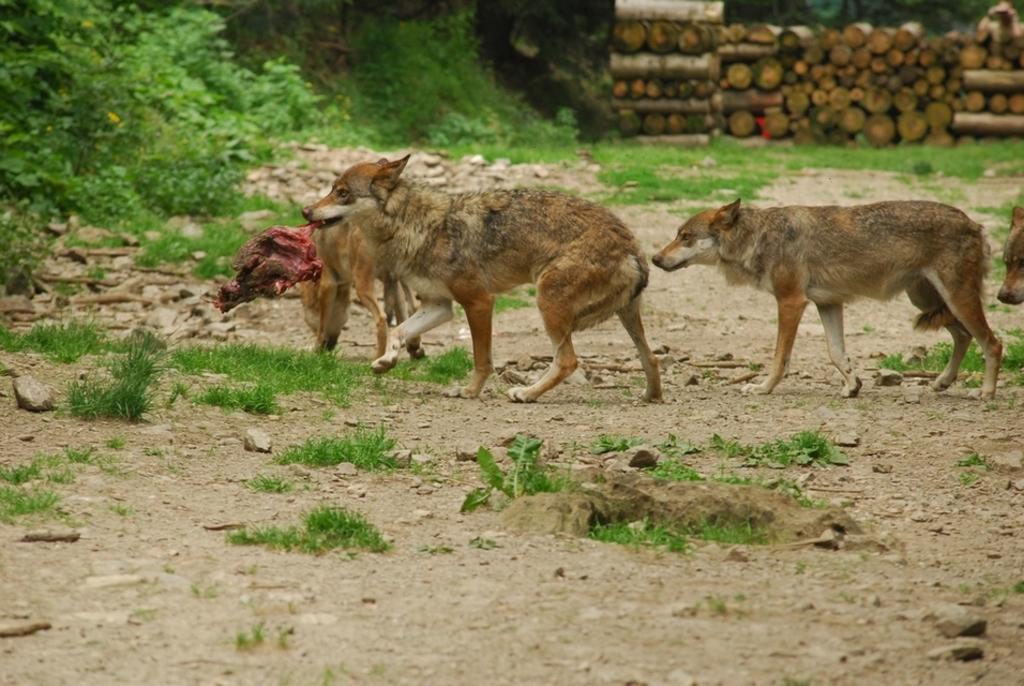Describe this image in one or two sentences. This picture is clicked outside. In the center we can see the animals seems to be walking on the ground and there is an animal holding the flesh in his mouth and seems to be walking on the ground. In the foreground we can see some portion of green grass. In the background we can see the green grass, plants and the wooden objects and some other objects. In the top right corner we can see a person like thing. 